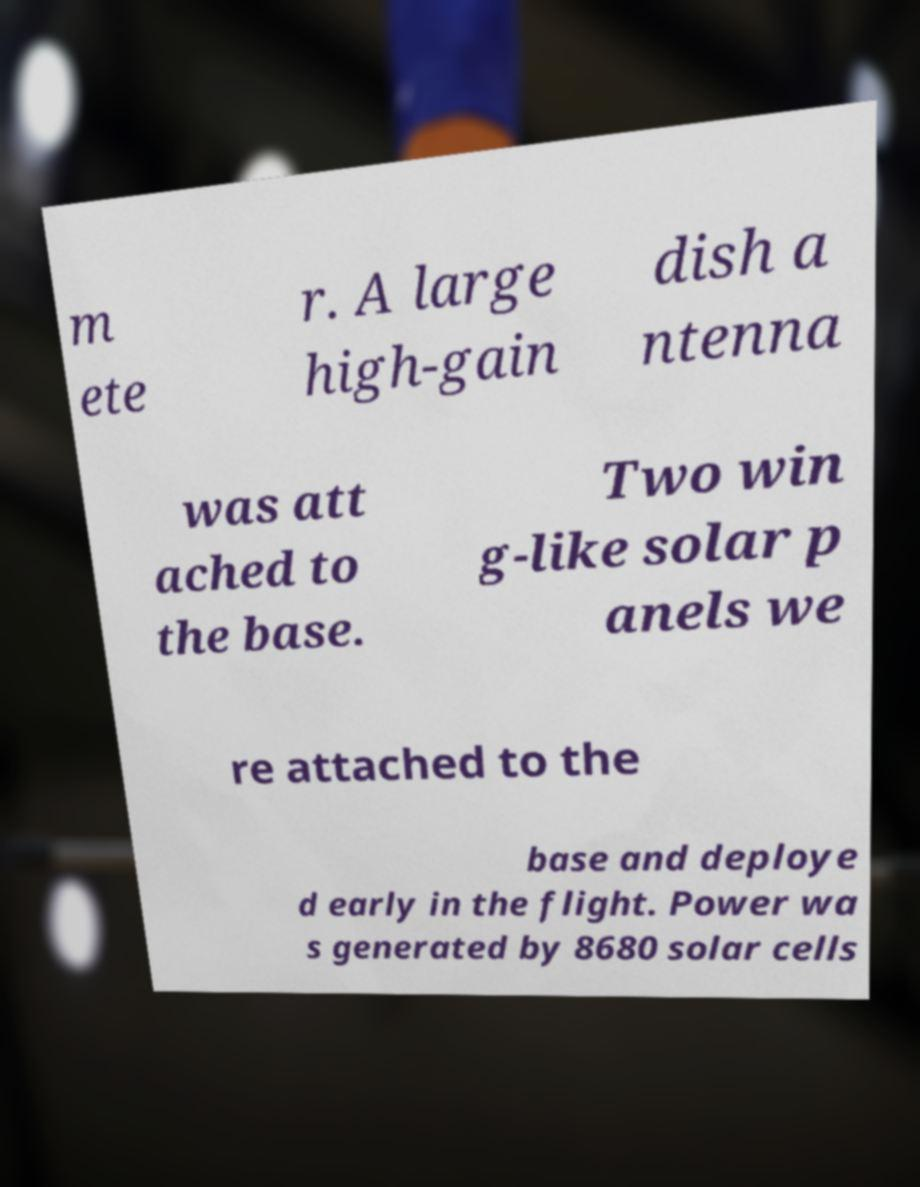Please read and relay the text visible in this image. What does it say? m ete r. A large high-gain dish a ntenna was att ached to the base. Two win g-like solar p anels we re attached to the base and deploye d early in the flight. Power wa s generated by 8680 solar cells 